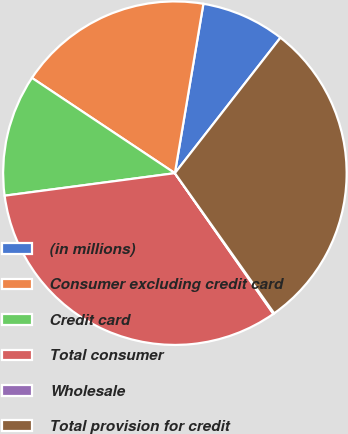<chart> <loc_0><loc_0><loc_500><loc_500><pie_chart><fcel>(in millions)<fcel>Consumer excluding credit card<fcel>Credit card<fcel>Total consumer<fcel>Wholesale<fcel>Total provision for credit<nl><fcel>7.88%<fcel>18.3%<fcel>11.45%<fcel>32.63%<fcel>0.09%<fcel>29.66%<nl></chart> 